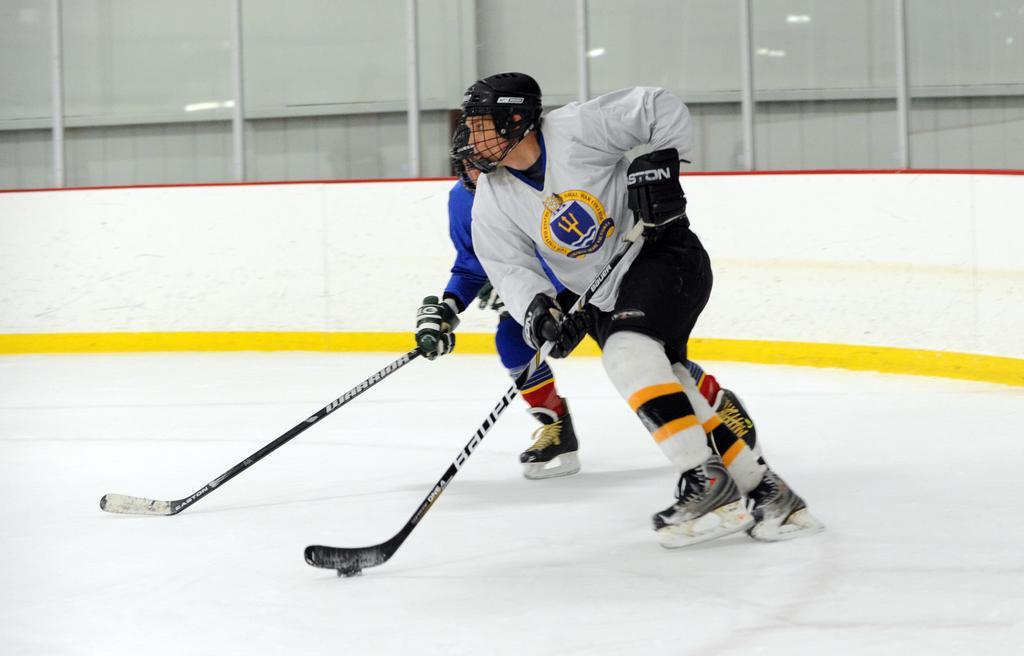Please provide a concise description of this image. In this image I can see two people with blue and ash color dresses and these are with black color helmets. I can see these people holding the sticks. They are also with ice skates and skating on the ice. In the background there is a wall. 